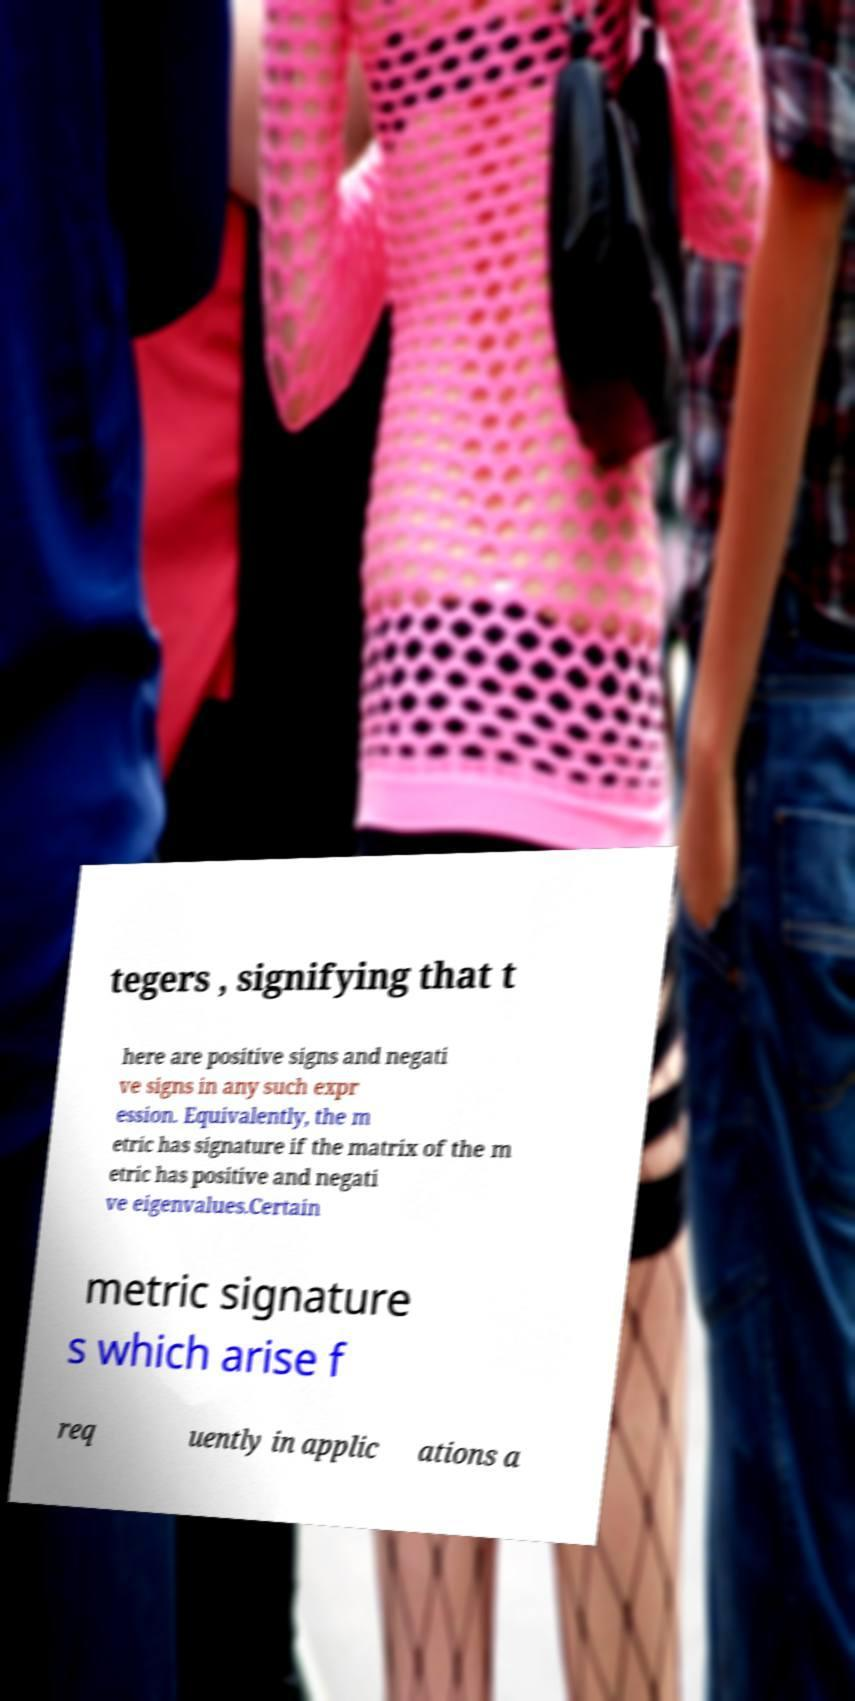For documentation purposes, I need the text within this image transcribed. Could you provide that? tegers , signifying that t here are positive signs and negati ve signs in any such expr ession. Equivalently, the m etric has signature if the matrix of the m etric has positive and negati ve eigenvalues.Certain metric signature s which arise f req uently in applic ations a 